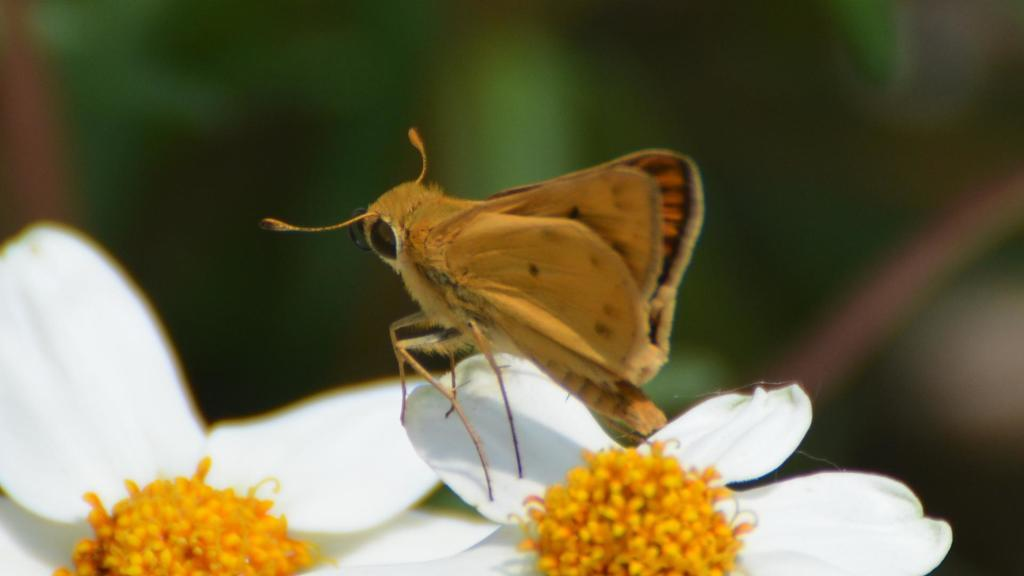What is the main subject of the picture? The main subject of the picture is an insect. Where is the insect located in the image? The insect is on a flower. Can you describe the background of the image? There are blurred things in the background of the image. Is the insect riding a bike in the image? No, there is no bike present in the image. The insect is on a flower. 